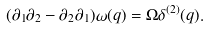<formula> <loc_0><loc_0><loc_500><loc_500>( \partial _ { 1 } \partial _ { 2 } - \partial _ { 2 } \partial _ { 1 } ) \omega ( q ) = \Omega \delta ^ { ( 2 ) } ( q ) .</formula> 